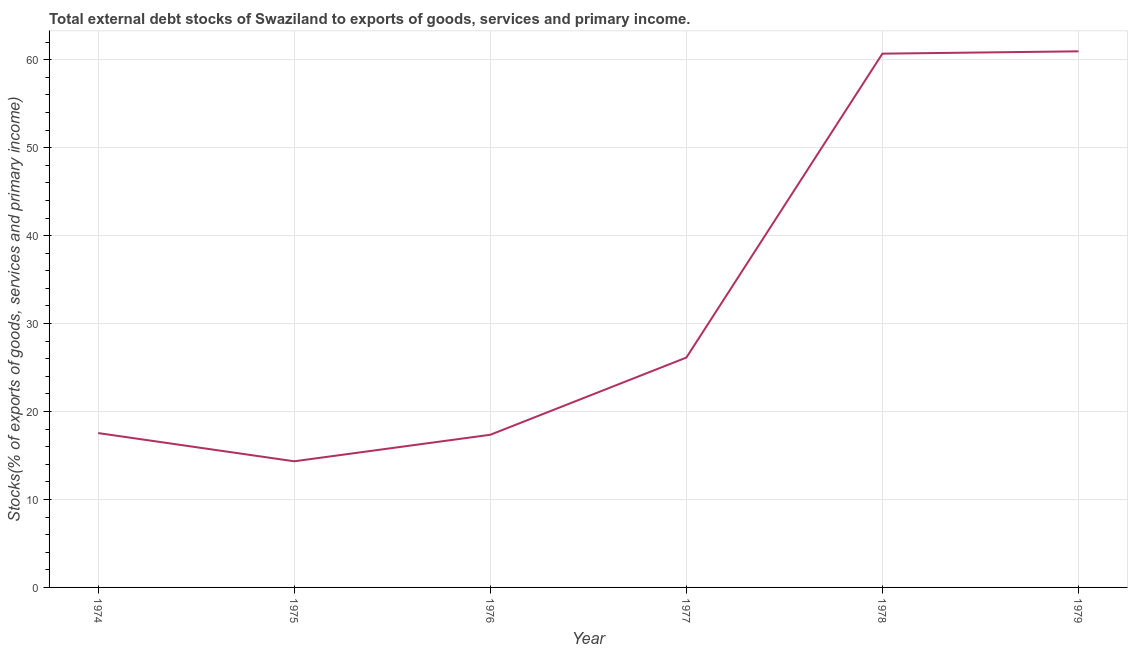What is the external debt stocks in 1974?
Your response must be concise. 17.55. Across all years, what is the maximum external debt stocks?
Give a very brief answer. 60.96. Across all years, what is the minimum external debt stocks?
Keep it short and to the point. 14.34. In which year was the external debt stocks maximum?
Offer a very short reply. 1979. In which year was the external debt stocks minimum?
Your response must be concise. 1975. What is the sum of the external debt stocks?
Ensure brevity in your answer.  197.03. What is the difference between the external debt stocks in 1977 and 1979?
Provide a succinct answer. -34.82. What is the average external debt stocks per year?
Your answer should be very brief. 32.84. What is the median external debt stocks?
Your response must be concise. 21.84. Do a majority of the years between 1974 and 1978 (inclusive) have external debt stocks greater than 14 %?
Your answer should be very brief. Yes. What is the ratio of the external debt stocks in 1974 to that in 1977?
Provide a succinct answer. 0.67. Is the external debt stocks in 1974 less than that in 1976?
Your response must be concise. No. What is the difference between the highest and the second highest external debt stocks?
Ensure brevity in your answer.  0.26. What is the difference between the highest and the lowest external debt stocks?
Give a very brief answer. 46.61. Does the external debt stocks monotonically increase over the years?
Ensure brevity in your answer.  No. How many lines are there?
Make the answer very short. 1. How many years are there in the graph?
Offer a very short reply. 6. Does the graph contain any zero values?
Keep it short and to the point. No. Does the graph contain grids?
Ensure brevity in your answer.  Yes. What is the title of the graph?
Your answer should be compact. Total external debt stocks of Swaziland to exports of goods, services and primary income. What is the label or title of the Y-axis?
Provide a short and direct response. Stocks(% of exports of goods, services and primary income). What is the Stocks(% of exports of goods, services and primary income) of 1974?
Keep it short and to the point. 17.55. What is the Stocks(% of exports of goods, services and primary income) in 1975?
Ensure brevity in your answer.  14.34. What is the Stocks(% of exports of goods, services and primary income) in 1976?
Keep it short and to the point. 17.36. What is the Stocks(% of exports of goods, services and primary income) in 1977?
Offer a terse response. 26.13. What is the Stocks(% of exports of goods, services and primary income) in 1978?
Offer a very short reply. 60.69. What is the Stocks(% of exports of goods, services and primary income) in 1979?
Offer a very short reply. 60.96. What is the difference between the Stocks(% of exports of goods, services and primary income) in 1974 and 1975?
Offer a terse response. 3.21. What is the difference between the Stocks(% of exports of goods, services and primary income) in 1974 and 1976?
Provide a succinct answer. 0.19. What is the difference between the Stocks(% of exports of goods, services and primary income) in 1974 and 1977?
Keep it short and to the point. -8.58. What is the difference between the Stocks(% of exports of goods, services and primary income) in 1974 and 1978?
Provide a short and direct response. -43.14. What is the difference between the Stocks(% of exports of goods, services and primary income) in 1974 and 1979?
Make the answer very short. -43.41. What is the difference between the Stocks(% of exports of goods, services and primary income) in 1975 and 1976?
Ensure brevity in your answer.  -3.02. What is the difference between the Stocks(% of exports of goods, services and primary income) in 1975 and 1977?
Offer a very short reply. -11.79. What is the difference between the Stocks(% of exports of goods, services and primary income) in 1975 and 1978?
Your answer should be very brief. -46.35. What is the difference between the Stocks(% of exports of goods, services and primary income) in 1975 and 1979?
Your answer should be compact. -46.61. What is the difference between the Stocks(% of exports of goods, services and primary income) in 1976 and 1977?
Your answer should be compact. -8.78. What is the difference between the Stocks(% of exports of goods, services and primary income) in 1976 and 1978?
Provide a succinct answer. -43.33. What is the difference between the Stocks(% of exports of goods, services and primary income) in 1976 and 1979?
Keep it short and to the point. -43.6. What is the difference between the Stocks(% of exports of goods, services and primary income) in 1977 and 1978?
Your answer should be compact. -34.56. What is the difference between the Stocks(% of exports of goods, services and primary income) in 1977 and 1979?
Provide a short and direct response. -34.82. What is the difference between the Stocks(% of exports of goods, services and primary income) in 1978 and 1979?
Keep it short and to the point. -0.26. What is the ratio of the Stocks(% of exports of goods, services and primary income) in 1974 to that in 1975?
Provide a short and direct response. 1.22. What is the ratio of the Stocks(% of exports of goods, services and primary income) in 1974 to that in 1977?
Offer a very short reply. 0.67. What is the ratio of the Stocks(% of exports of goods, services and primary income) in 1974 to that in 1978?
Your response must be concise. 0.29. What is the ratio of the Stocks(% of exports of goods, services and primary income) in 1974 to that in 1979?
Keep it short and to the point. 0.29. What is the ratio of the Stocks(% of exports of goods, services and primary income) in 1975 to that in 1976?
Provide a succinct answer. 0.83. What is the ratio of the Stocks(% of exports of goods, services and primary income) in 1975 to that in 1977?
Ensure brevity in your answer.  0.55. What is the ratio of the Stocks(% of exports of goods, services and primary income) in 1975 to that in 1978?
Keep it short and to the point. 0.24. What is the ratio of the Stocks(% of exports of goods, services and primary income) in 1975 to that in 1979?
Give a very brief answer. 0.23. What is the ratio of the Stocks(% of exports of goods, services and primary income) in 1976 to that in 1977?
Make the answer very short. 0.66. What is the ratio of the Stocks(% of exports of goods, services and primary income) in 1976 to that in 1978?
Make the answer very short. 0.29. What is the ratio of the Stocks(% of exports of goods, services and primary income) in 1976 to that in 1979?
Give a very brief answer. 0.28. What is the ratio of the Stocks(% of exports of goods, services and primary income) in 1977 to that in 1978?
Keep it short and to the point. 0.43. What is the ratio of the Stocks(% of exports of goods, services and primary income) in 1977 to that in 1979?
Your response must be concise. 0.43. What is the ratio of the Stocks(% of exports of goods, services and primary income) in 1978 to that in 1979?
Ensure brevity in your answer.  1. 